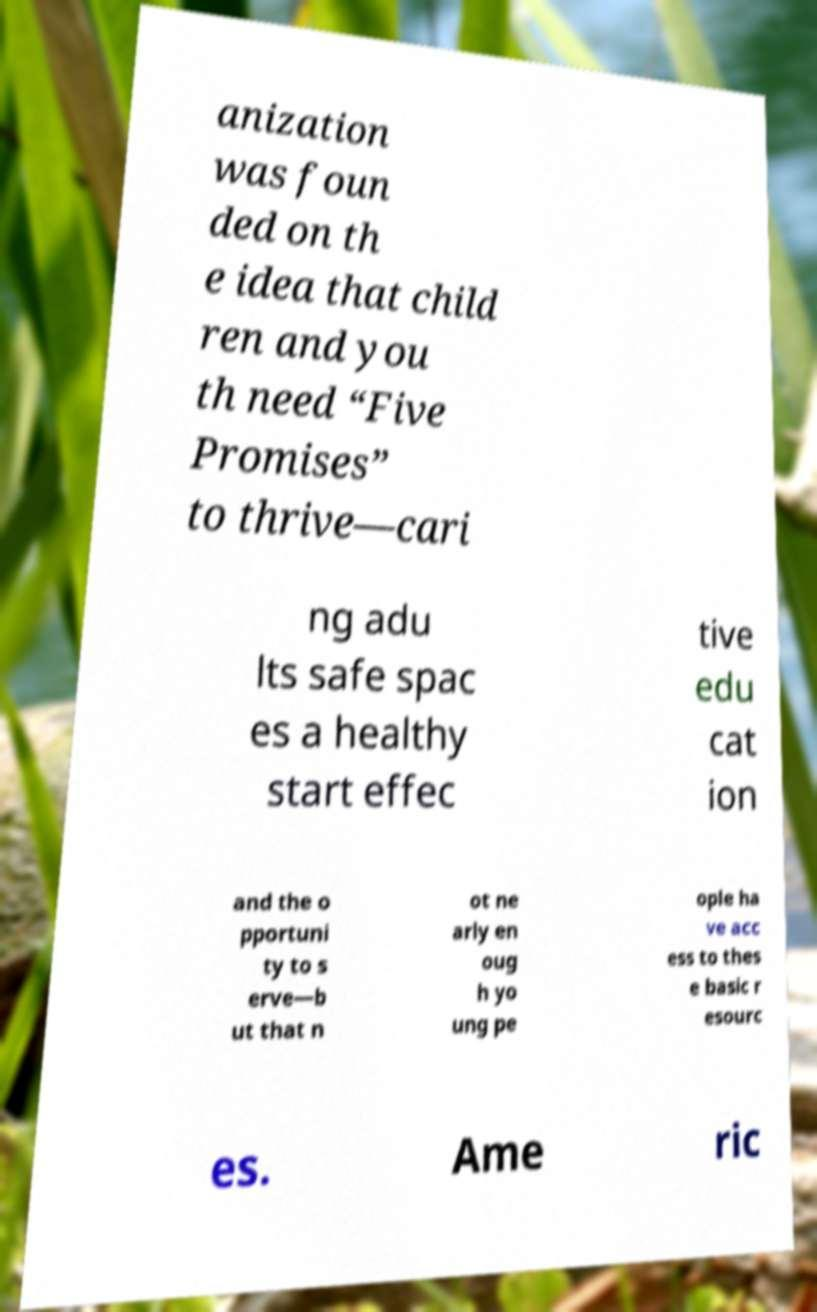Please identify and transcribe the text found in this image. anization was foun ded on th e idea that child ren and you th need “Five Promises” to thrive—cari ng adu lts safe spac es a healthy start effec tive edu cat ion and the o pportuni ty to s erve—b ut that n ot ne arly en oug h yo ung pe ople ha ve acc ess to thes e basic r esourc es. Ame ric 